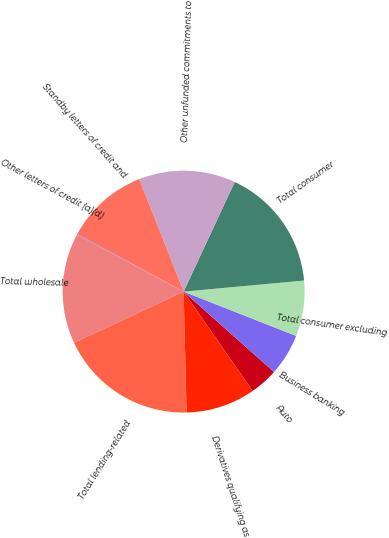<chart> <loc_0><loc_0><loc_500><loc_500><pie_chart><fcel>Auto<fcel>Business banking<fcel>Total consumer excluding<fcel>Total consumer<fcel>Other unfunded commitments to<fcel>Standby letters of credit and<fcel>Other letters of credit (a)(d)<fcel>Total wholesale<fcel>Total lending-related<fcel>Derivatives qualifying as<nl><fcel>3.77%<fcel>5.6%<fcel>7.43%<fcel>16.6%<fcel>12.93%<fcel>11.1%<fcel>0.1%<fcel>14.77%<fcel>18.43%<fcel>9.27%<nl></chart> 